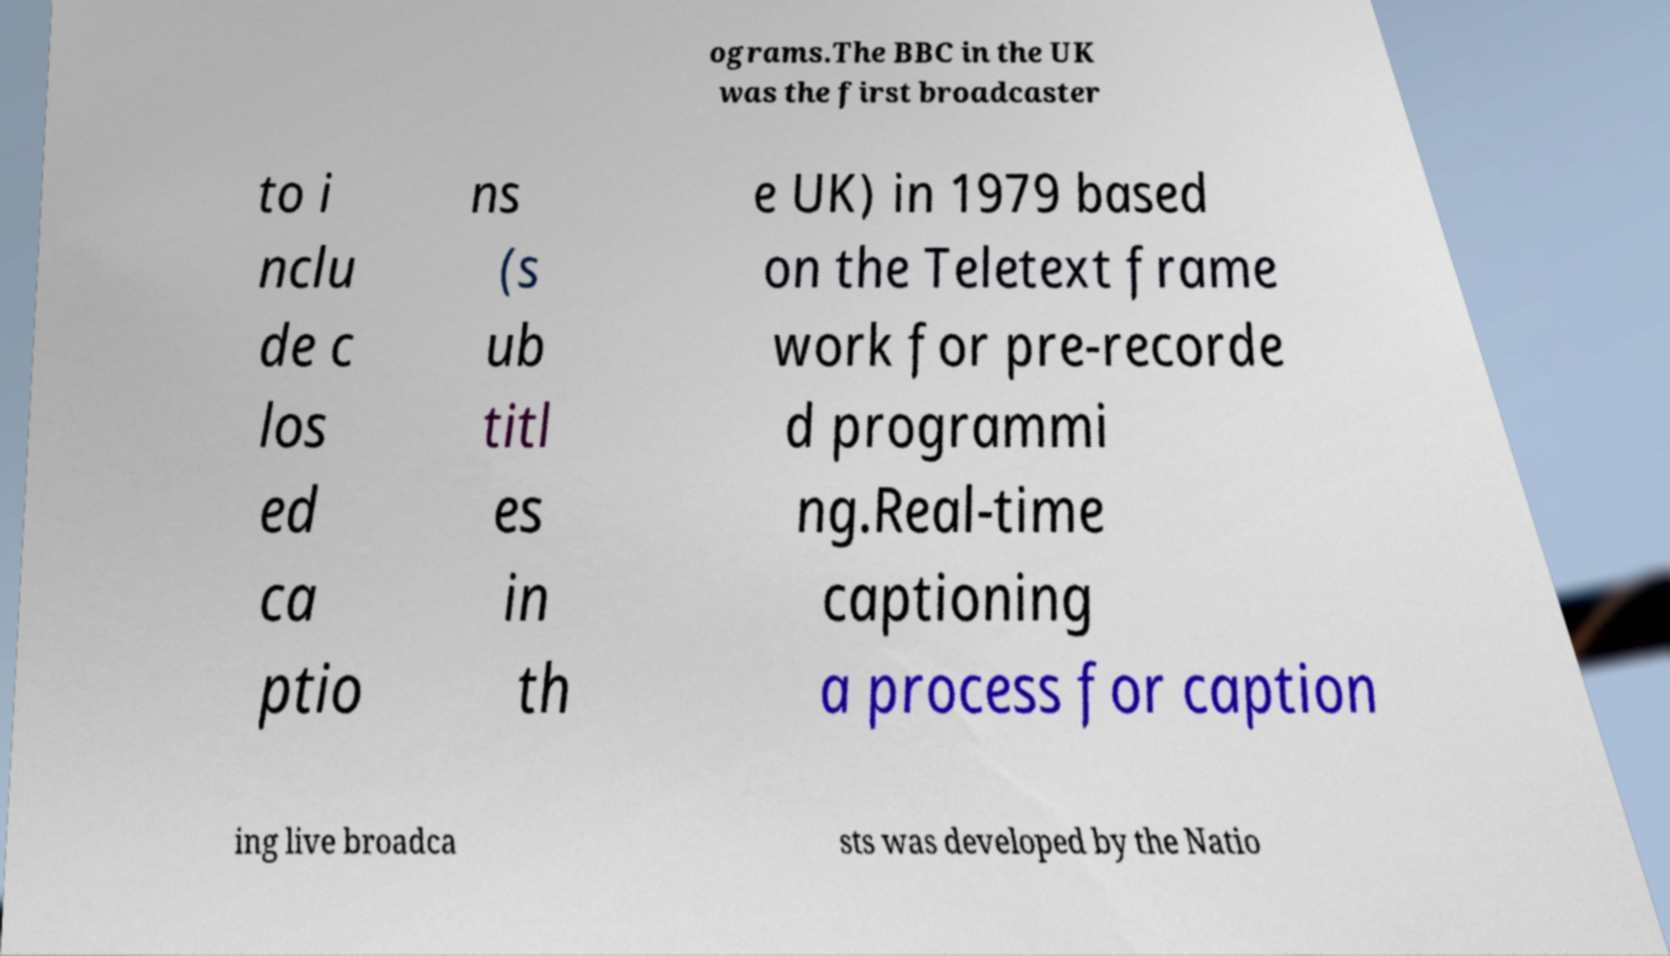Could you extract and type out the text from this image? ograms.The BBC in the UK was the first broadcaster to i nclu de c los ed ca ptio ns (s ub titl es in th e UK) in 1979 based on the Teletext frame work for pre-recorde d programmi ng.Real-time captioning a process for caption ing live broadca sts was developed by the Natio 